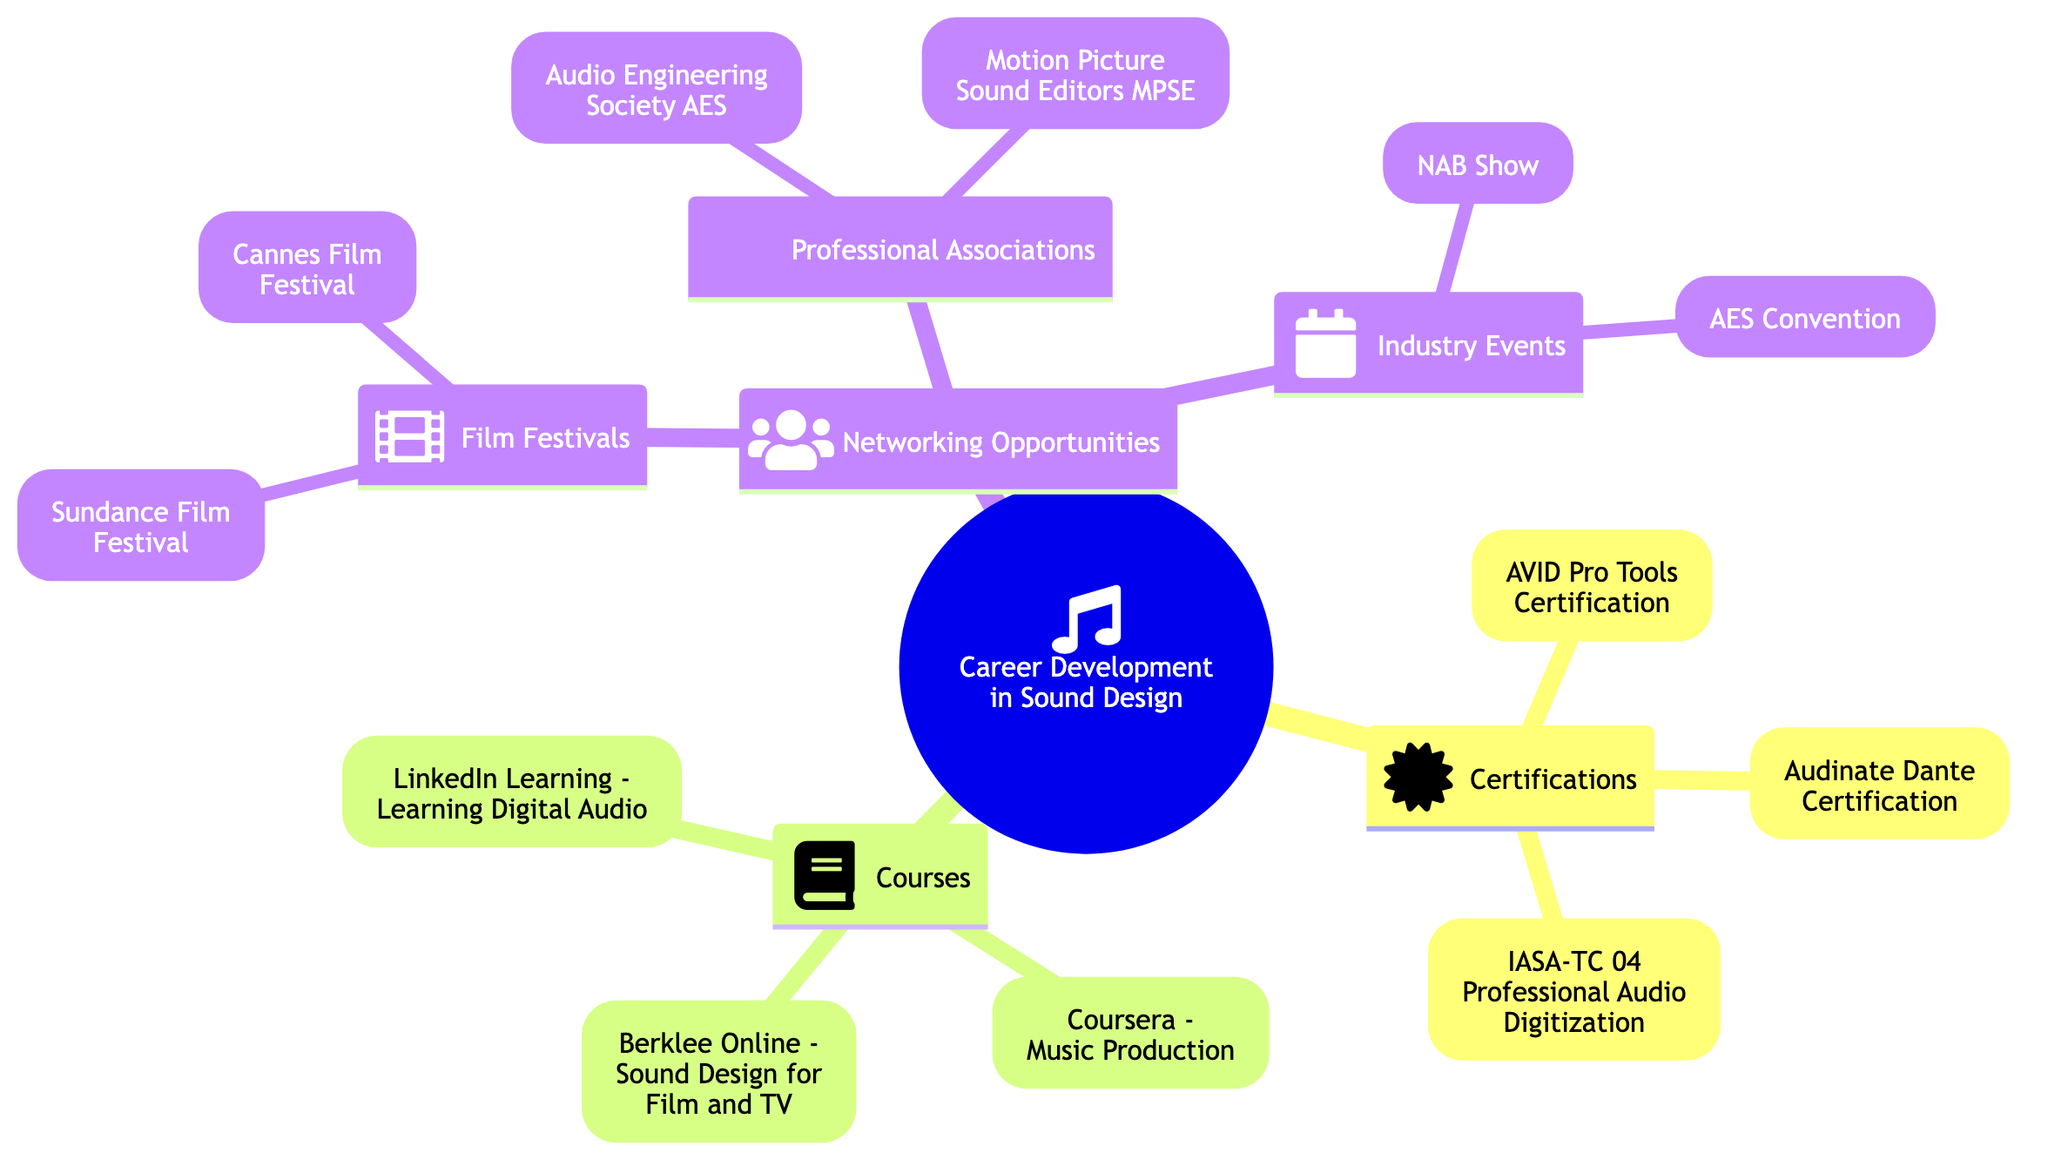What are the three categories listed under "Career Development in Sound Design"? The diagram displays three main categories under "Career Development in Sound Design": Certifications, Courses, and Networking Opportunities. This information can be found at the top-level nodes directly connected to the root.
Answer: Certifications, Courses, Networking Opportunities How many certifications are listed in the diagram? The diagram provides three certifications: AVID Pro Tools Certification, Audinate Dante Certification, and IASA-TC 04 Professional Audio Digitization. By counting these, the total comes to three certifications.
Answer: 3 Which course focuses specifically on sound design for visual media? Among the courses listed, the one specifically covering sound design techniques for visual media is "Berklee Online - Sound Design for Film and TV." This can be identified by examining the listed course node details.
Answer: Berklee Online - Sound Design for Film and TV What two major film festivals are mentioned as networking opportunities? In the "Networking Opportunities" section, the two film festivals identified are Sundance Film Festival and Cannes Film Festival. They are both part of the nested structure under Film Festivals.
Answer: Sundance Film Festival, Cannes Film Festival Which professional association is represented by the acronym AES? The acronym AES stands for Audio Engineering Society, which is listed under the "Professional Associations" section. This can be found by locating the node associated with the acronym in the diagram.
Answer: Audio Engineering Society Are certifications or courses grouped more prominently in the diagram? The diagram structurally places "Certifications" and "Courses" as equal top-level categories branching from the root node, with no indication of one being more prominent than the other. They have the same hierarchical level and layout.
Answer: Equal prominence What is the purpose of the NAB Show as listed in the diagram? The NAB Show is described in the diagram as a major event for broadcast and media professionals, including sound designers, highlighting its importance in the industry. This information is found under the "Industry Events" section.
Answer: Major event for broadcast and media professionals How many networking opportunities are detailed under "Industry Events"? There are two networking opportunities detailed under "Industry Events": NAB Show and AES Convention. By counting these listed events, the total comes to two opportunities.
Answer: 2 Which certification is specifically for audio digitization and restoration? The certification specifically focused on archival audio digitization and restoration is IASA-TC 04 Professional Audio Digitization. This can be seen in the Certifications section of the diagram.
Answer: IASA-TC 04 Professional Audio Digitization 